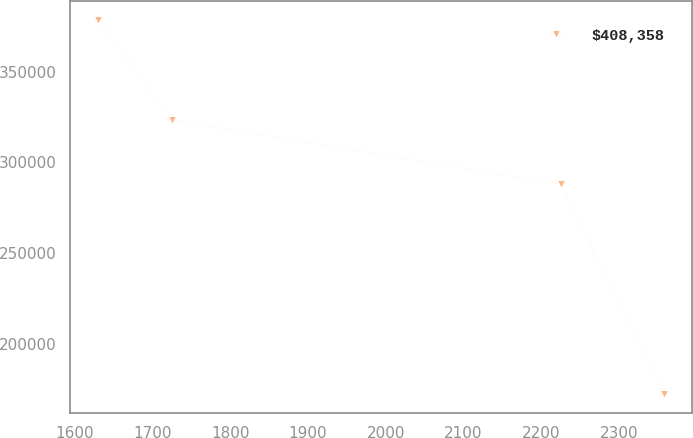Convert chart. <chart><loc_0><loc_0><loc_500><loc_500><line_chart><ecel><fcel>$408,358<nl><fcel>1630.04<fcel>378586<nl><fcel>1725.57<fcel>323336<nl><fcel>2225.25<fcel>287875<nl><fcel>2357.31<fcel>172227<nl></chart> 